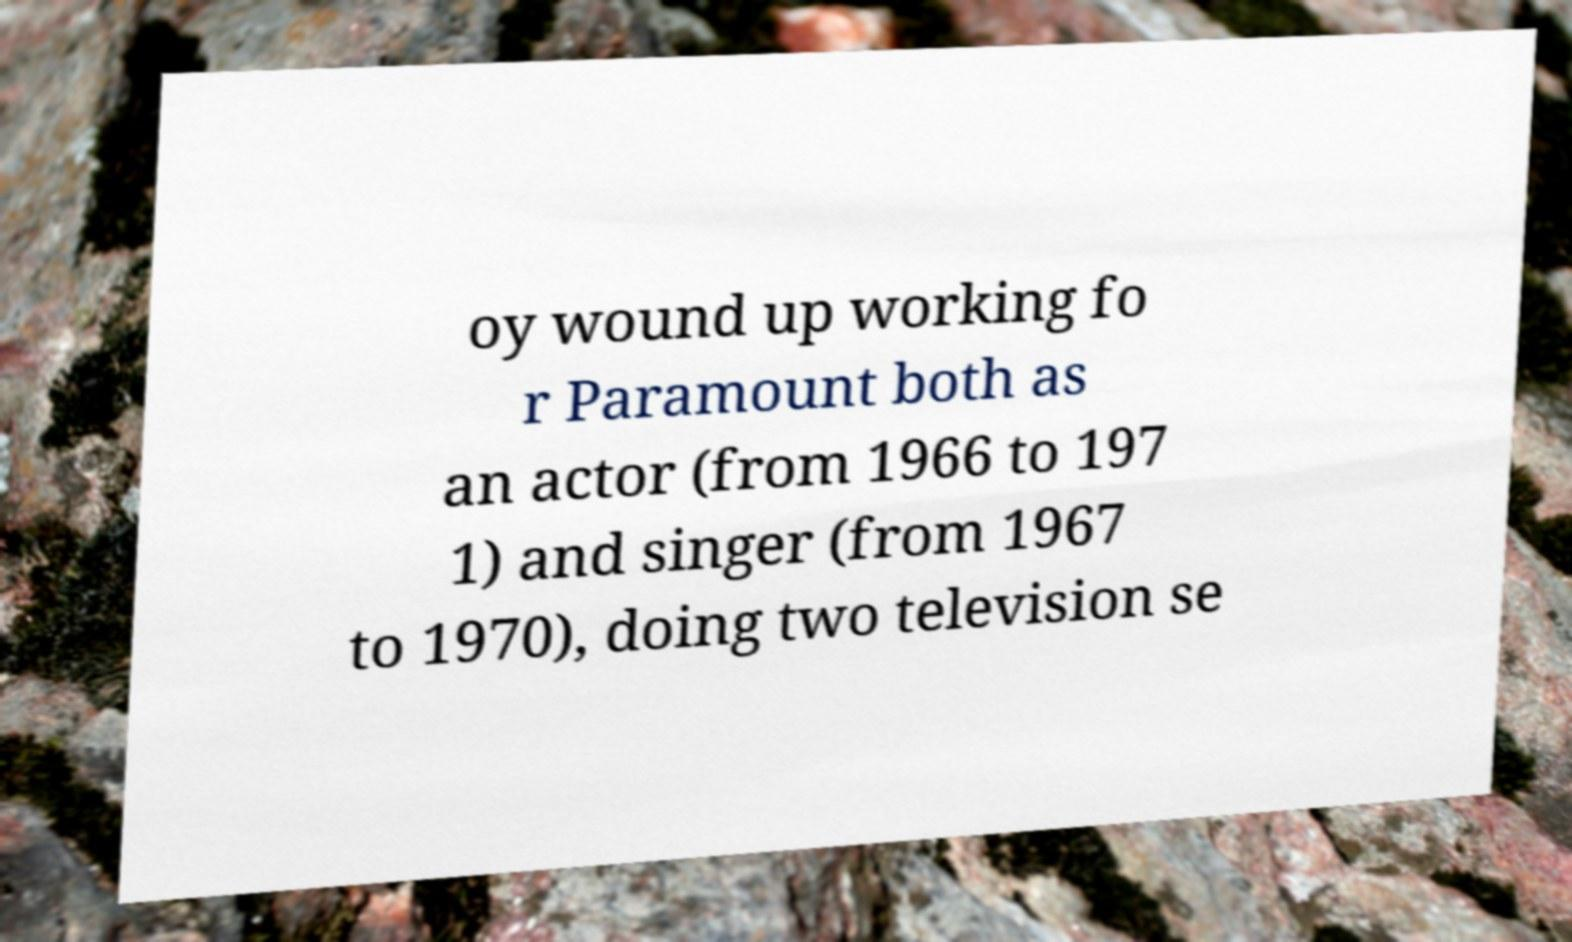For documentation purposes, I need the text within this image transcribed. Could you provide that? oy wound up working fo r Paramount both as an actor (from 1966 to 197 1) and singer (from 1967 to 1970), doing two television se 